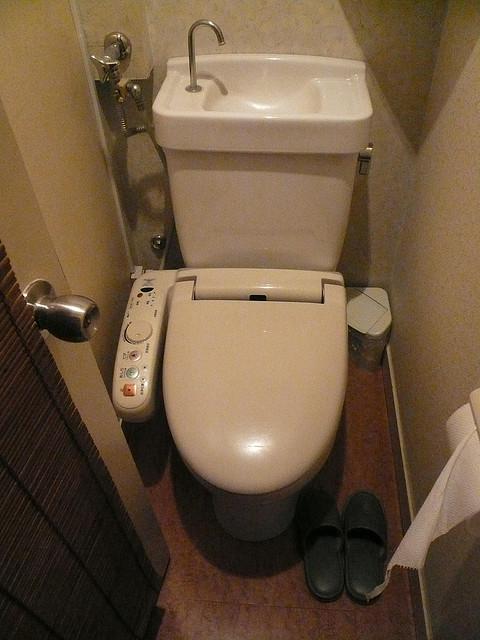What color is the toilet?
Concise answer only. White. What is behind the toilet?
Keep it brief. Sink. Is this room large or small?
Keep it brief. Small. Is this a private restroom?
Be succinct. Yes. Is the toilet paper coming over the top or from below?
Quick response, please. Over top. 